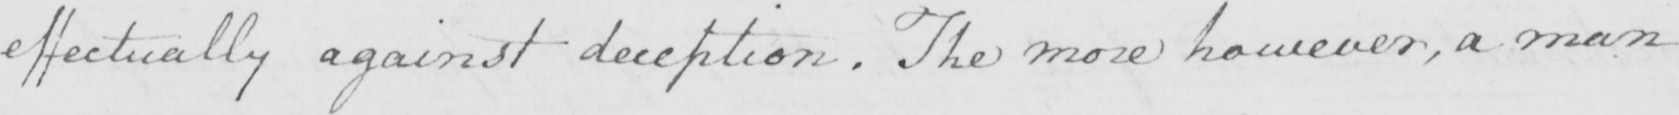Please transcribe the handwritten text in this image. effectually against deception . The more however , a man 